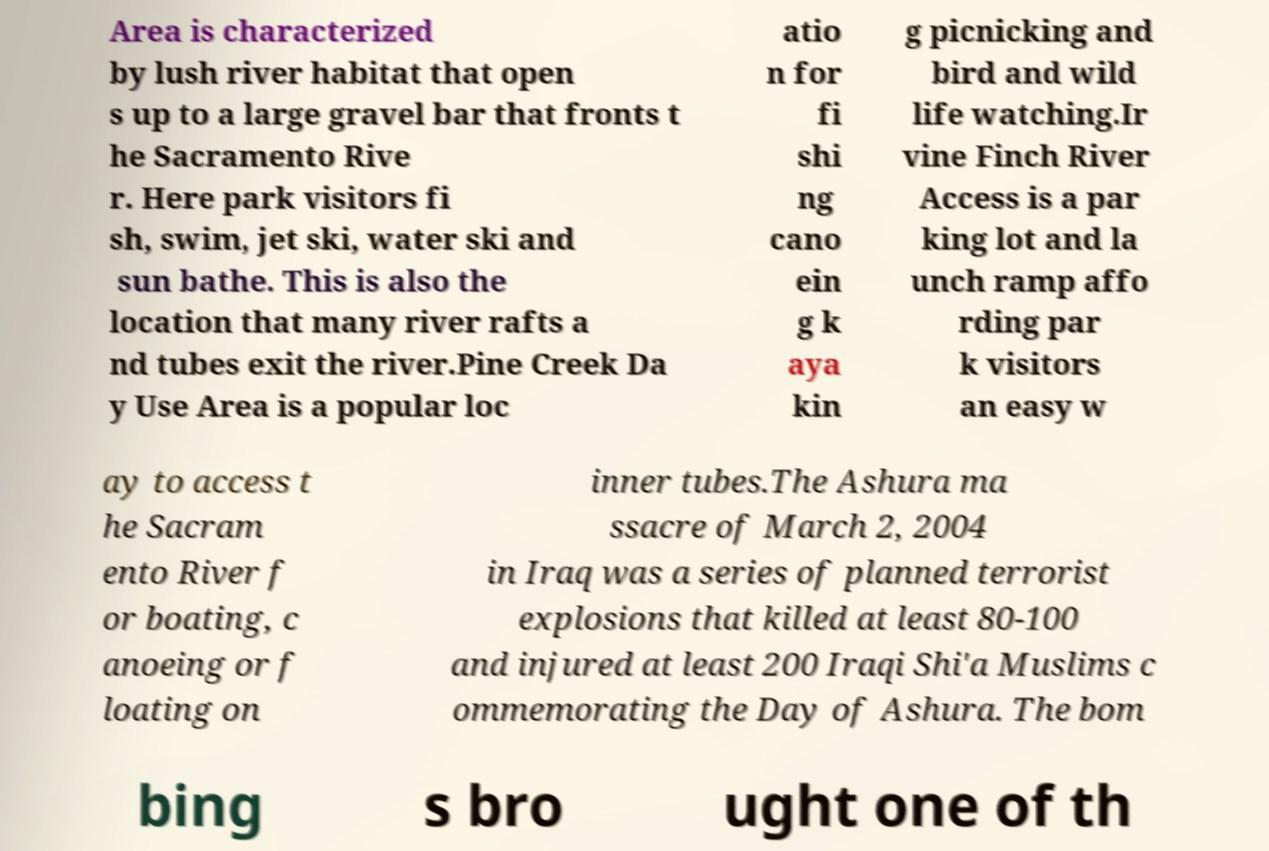Could you assist in decoding the text presented in this image and type it out clearly? Area is characterized by lush river habitat that open s up to a large gravel bar that fronts t he Sacramento Rive r. Here park visitors fi sh, swim, jet ski, water ski and sun bathe. This is also the location that many river rafts a nd tubes exit the river.Pine Creek Da y Use Area is a popular loc atio n for fi shi ng cano ein g k aya kin g picnicking and bird and wild life watching.Ir vine Finch River Access is a par king lot and la unch ramp affo rding par k visitors an easy w ay to access t he Sacram ento River f or boating, c anoeing or f loating on inner tubes.The Ashura ma ssacre of March 2, 2004 in Iraq was a series of planned terrorist explosions that killed at least 80-100 and injured at least 200 Iraqi Shi'a Muslims c ommemorating the Day of Ashura. The bom bing s bro ught one of th 